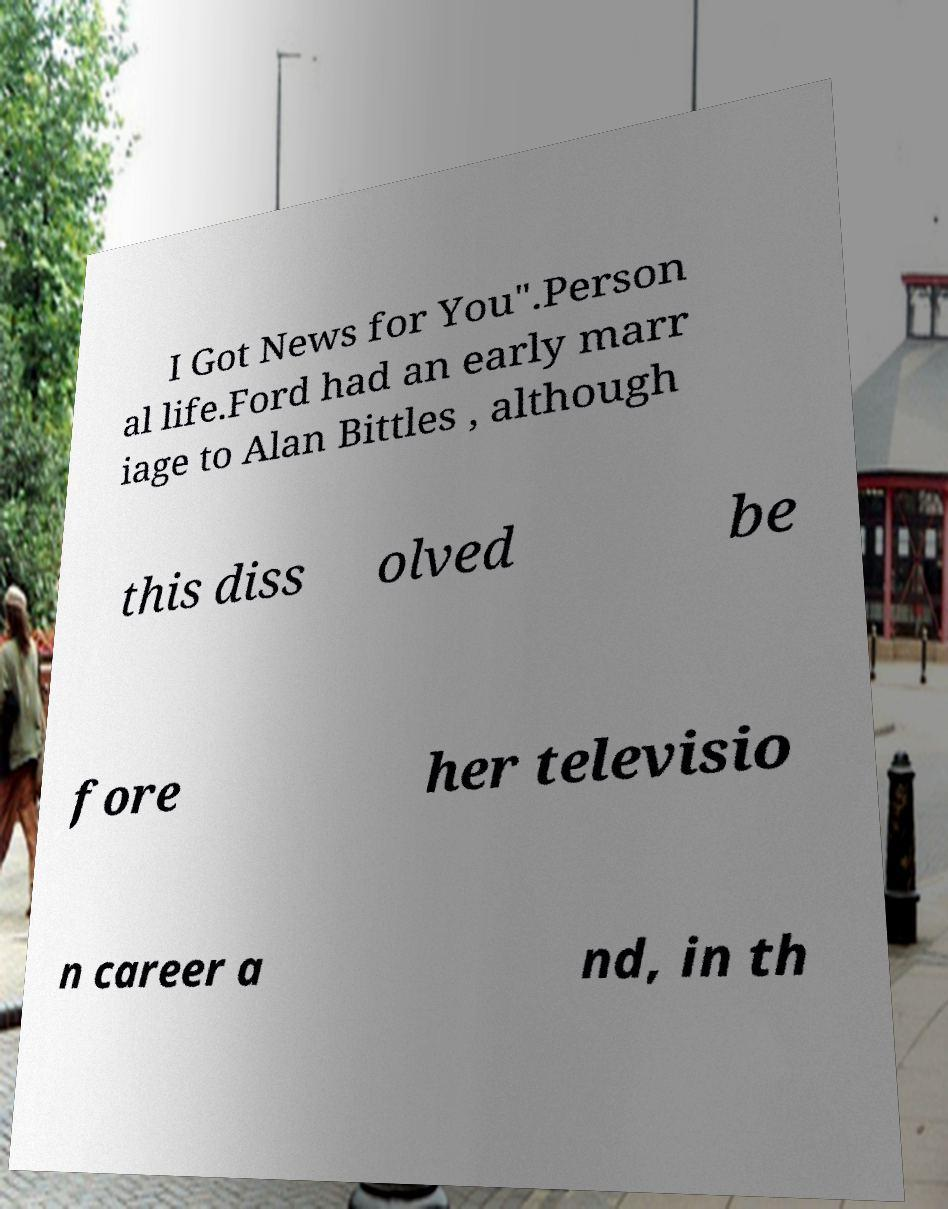What messages or text are displayed in this image? I need them in a readable, typed format. I Got News for You".Person al life.Ford had an early marr iage to Alan Bittles , although this diss olved be fore her televisio n career a nd, in th 